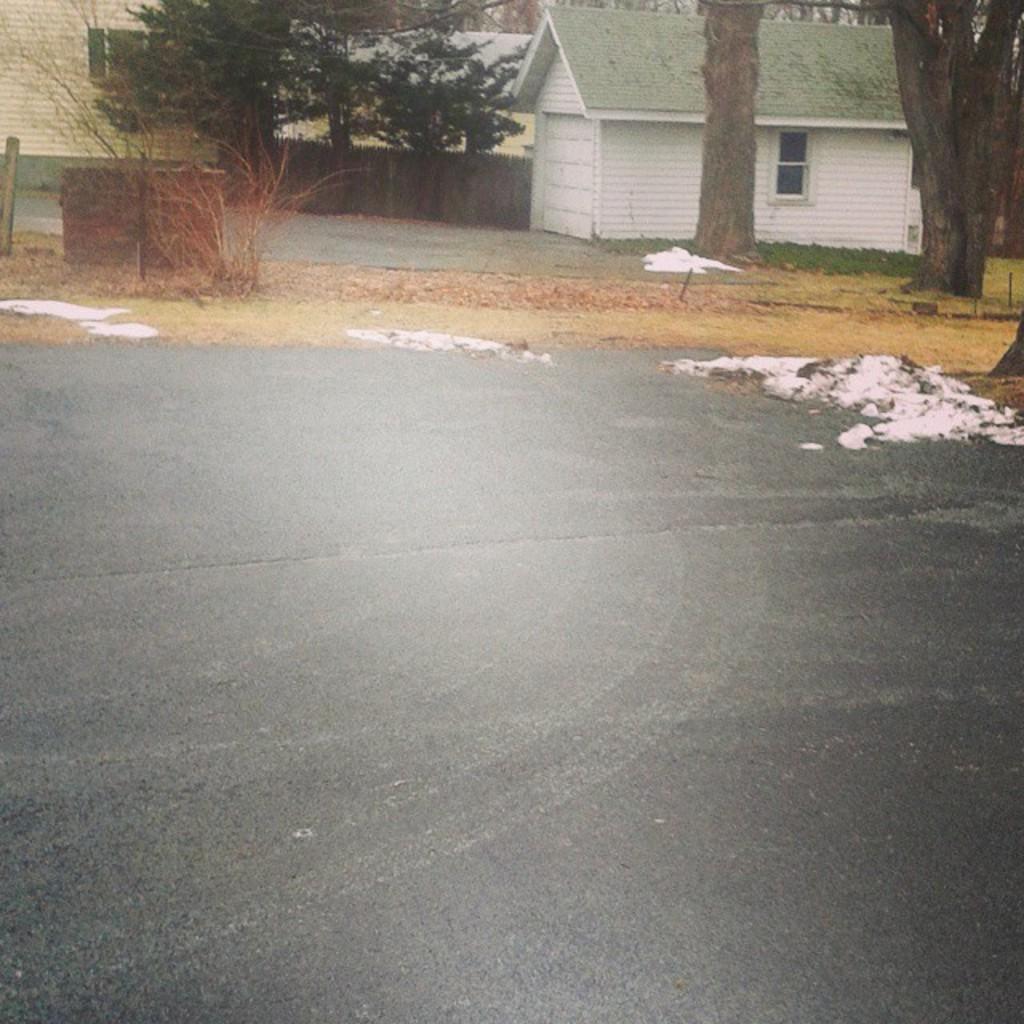Please provide a concise description of this image. In this image, we can see sheds, trees, plants and there is a pole and a wall and at the bottom, there is some snow on the road. 